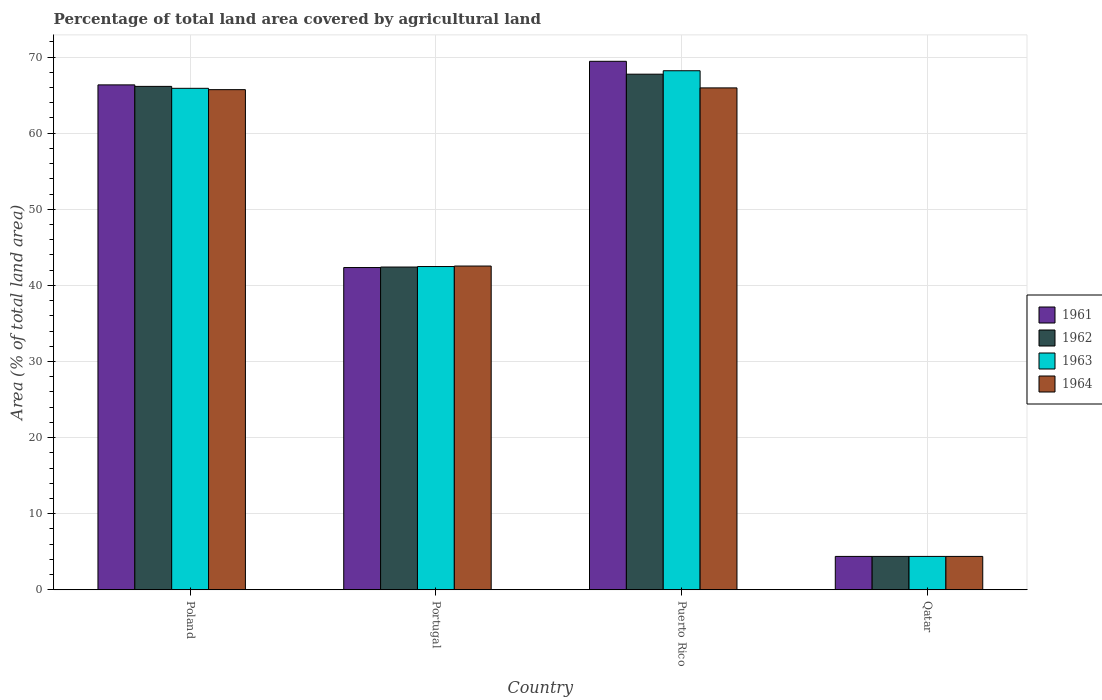How many different coloured bars are there?
Provide a short and direct response. 4. How many groups of bars are there?
Offer a terse response. 4. Are the number of bars on each tick of the X-axis equal?
Provide a succinct answer. Yes. How many bars are there on the 4th tick from the left?
Keep it short and to the point. 4. What is the label of the 3rd group of bars from the left?
Your response must be concise. Puerto Rico. What is the percentage of agricultural land in 1964 in Portugal?
Provide a short and direct response. 42.55. Across all countries, what is the maximum percentage of agricultural land in 1964?
Make the answer very short. 65.95. Across all countries, what is the minimum percentage of agricultural land in 1961?
Offer a terse response. 4.39. In which country was the percentage of agricultural land in 1964 maximum?
Offer a very short reply. Puerto Rico. In which country was the percentage of agricultural land in 1961 minimum?
Give a very brief answer. Qatar. What is the total percentage of agricultural land in 1961 in the graph?
Ensure brevity in your answer.  182.54. What is the difference between the percentage of agricultural land in 1963 in Portugal and that in Puerto Rico?
Your answer should be compact. -25.73. What is the difference between the percentage of agricultural land in 1962 in Portugal and the percentage of agricultural land in 1963 in Qatar?
Offer a terse response. 38.02. What is the average percentage of agricultural land in 1961 per country?
Your response must be concise. 45.63. What is the difference between the percentage of agricultural land of/in 1961 and percentage of agricultural land of/in 1963 in Qatar?
Provide a succinct answer. 0. In how many countries, is the percentage of agricultural land in 1963 greater than 64 %?
Your response must be concise. 2. What is the ratio of the percentage of agricultural land in 1964 in Poland to that in Portugal?
Make the answer very short. 1.54. Is the percentage of agricultural land in 1964 in Poland less than that in Puerto Rico?
Give a very brief answer. Yes. Is the difference between the percentage of agricultural land in 1961 in Poland and Qatar greater than the difference between the percentage of agricultural land in 1963 in Poland and Qatar?
Your answer should be compact. Yes. What is the difference between the highest and the second highest percentage of agricultural land in 1964?
Your response must be concise. -0.23. What is the difference between the highest and the lowest percentage of agricultural land in 1964?
Provide a short and direct response. 61.56. In how many countries, is the percentage of agricultural land in 1963 greater than the average percentage of agricultural land in 1963 taken over all countries?
Offer a very short reply. 2. Is the sum of the percentage of agricultural land in 1964 in Poland and Portugal greater than the maximum percentage of agricultural land in 1962 across all countries?
Make the answer very short. Yes. What does the 2nd bar from the right in Portugal represents?
Keep it short and to the point. 1963. Is it the case that in every country, the sum of the percentage of agricultural land in 1964 and percentage of agricultural land in 1961 is greater than the percentage of agricultural land in 1962?
Your answer should be compact. Yes. How many bars are there?
Your answer should be compact. 16. Are all the bars in the graph horizontal?
Keep it short and to the point. No. Does the graph contain grids?
Provide a succinct answer. Yes. What is the title of the graph?
Offer a very short reply. Percentage of total land area covered by agricultural land. Does "1977" appear as one of the legend labels in the graph?
Your response must be concise. No. What is the label or title of the X-axis?
Make the answer very short. Country. What is the label or title of the Y-axis?
Keep it short and to the point. Area (% of total land area). What is the Area (% of total land area) of 1961 in Poland?
Ensure brevity in your answer.  66.35. What is the Area (% of total land area) of 1962 in Poland?
Your answer should be very brief. 66.15. What is the Area (% of total land area) in 1963 in Poland?
Keep it short and to the point. 65.9. What is the Area (% of total land area) in 1964 in Poland?
Offer a terse response. 65.72. What is the Area (% of total land area) of 1961 in Portugal?
Offer a terse response. 42.35. What is the Area (% of total land area) in 1962 in Portugal?
Ensure brevity in your answer.  42.42. What is the Area (% of total land area) of 1963 in Portugal?
Make the answer very short. 42.48. What is the Area (% of total land area) in 1964 in Portugal?
Offer a terse response. 42.55. What is the Area (% of total land area) in 1961 in Puerto Rico?
Your answer should be compact. 69.45. What is the Area (% of total land area) of 1962 in Puerto Rico?
Offer a terse response. 67.76. What is the Area (% of total land area) in 1963 in Puerto Rico?
Keep it short and to the point. 68.21. What is the Area (% of total land area) in 1964 in Puerto Rico?
Provide a succinct answer. 65.95. What is the Area (% of total land area) of 1961 in Qatar?
Provide a short and direct response. 4.39. What is the Area (% of total land area) in 1962 in Qatar?
Give a very brief answer. 4.39. What is the Area (% of total land area) in 1963 in Qatar?
Ensure brevity in your answer.  4.39. What is the Area (% of total land area) of 1964 in Qatar?
Ensure brevity in your answer.  4.39. Across all countries, what is the maximum Area (% of total land area) of 1961?
Make the answer very short. 69.45. Across all countries, what is the maximum Area (% of total land area) of 1962?
Ensure brevity in your answer.  67.76. Across all countries, what is the maximum Area (% of total land area) in 1963?
Give a very brief answer. 68.21. Across all countries, what is the maximum Area (% of total land area) of 1964?
Your answer should be compact. 65.95. Across all countries, what is the minimum Area (% of total land area) of 1961?
Ensure brevity in your answer.  4.39. Across all countries, what is the minimum Area (% of total land area) of 1962?
Your answer should be compact. 4.39. Across all countries, what is the minimum Area (% of total land area) in 1963?
Ensure brevity in your answer.  4.39. Across all countries, what is the minimum Area (% of total land area) of 1964?
Provide a short and direct response. 4.39. What is the total Area (% of total land area) of 1961 in the graph?
Your response must be concise. 182.54. What is the total Area (% of total land area) of 1962 in the graph?
Provide a short and direct response. 180.72. What is the total Area (% of total land area) in 1963 in the graph?
Provide a short and direct response. 180.98. What is the total Area (% of total land area) of 1964 in the graph?
Ensure brevity in your answer.  178.61. What is the difference between the Area (% of total land area) of 1961 in Poland and that in Portugal?
Your answer should be very brief. 24. What is the difference between the Area (% of total land area) of 1962 in Poland and that in Portugal?
Keep it short and to the point. 23.74. What is the difference between the Area (% of total land area) in 1963 in Poland and that in Portugal?
Ensure brevity in your answer.  23.42. What is the difference between the Area (% of total land area) in 1964 in Poland and that in Portugal?
Offer a very short reply. 23.18. What is the difference between the Area (% of total land area) in 1961 in Poland and that in Puerto Rico?
Give a very brief answer. -3.1. What is the difference between the Area (% of total land area) in 1962 in Poland and that in Puerto Rico?
Make the answer very short. -1.6. What is the difference between the Area (% of total land area) in 1963 in Poland and that in Puerto Rico?
Your answer should be compact. -2.31. What is the difference between the Area (% of total land area) in 1964 in Poland and that in Puerto Rico?
Provide a short and direct response. -0.23. What is the difference between the Area (% of total land area) in 1961 in Poland and that in Qatar?
Your response must be concise. 61.96. What is the difference between the Area (% of total land area) of 1962 in Poland and that in Qatar?
Provide a short and direct response. 61.76. What is the difference between the Area (% of total land area) in 1963 in Poland and that in Qatar?
Make the answer very short. 61.51. What is the difference between the Area (% of total land area) of 1964 in Poland and that in Qatar?
Make the answer very short. 61.33. What is the difference between the Area (% of total land area) in 1961 in Portugal and that in Puerto Rico?
Your response must be concise. -27.1. What is the difference between the Area (% of total land area) of 1962 in Portugal and that in Puerto Rico?
Your answer should be compact. -25.34. What is the difference between the Area (% of total land area) in 1963 in Portugal and that in Puerto Rico?
Offer a terse response. -25.73. What is the difference between the Area (% of total land area) of 1964 in Portugal and that in Puerto Rico?
Provide a short and direct response. -23.41. What is the difference between the Area (% of total land area) of 1961 in Portugal and that in Qatar?
Offer a very short reply. 37.96. What is the difference between the Area (% of total land area) in 1962 in Portugal and that in Qatar?
Offer a terse response. 38.02. What is the difference between the Area (% of total land area) of 1963 in Portugal and that in Qatar?
Your answer should be compact. 38.09. What is the difference between the Area (% of total land area) of 1964 in Portugal and that in Qatar?
Provide a succinct answer. 38.15. What is the difference between the Area (% of total land area) in 1961 in Puerto Rico and that in Qatar?
Your response must be concise. 65.05. What is the difference between the Area (% of total land area) of 1962 in Puerto Rico and that in Qatar?
Your response must be concise. 63.36. What is the difference between the Area (% of total land area) of 1963 in Puerto Rico and that in Qatar?
Give a very brief answer. 63.81. What is the difference between the Area (% of total land area) in 1964 in Puerto Rico and that in Qatar?
Give a very brief answer. 61.56. What is the difference between the Area (% of total land area) of 1961 in Poland and the Area (% of total land area) of 1962 in Portugal?
Your answer should be very brief. 23.93. What is the difference between the Area (% of total land area) in 1961 in Poland and the Area (% of total land area) in 1963 in Portugal?
Ensure brevity in your answer.  23.87. What is the difference between the Area (% of total land area) in 1961 in Poland and the Area (% of total land area) in 1964 in Portugal?
Your answer should be compact. 23.8. What is the difference between the Area (% of total land area) in 1962 in Poland and the Area (% of total land area) in 1963 in Portugal?
Offer a terse response. 23.67. What is the difference between the Area (% of total land area) of 1962 in Poland and the Area (% of total land area) of 1964 in Portugal?
Make the answer very short. 23.61. What is the difference between the Area (% of total land area) of 1963 in Poland and the Area (% of total land area) of 1964 in Portugal?
Offer a very short reply. 23.35. What is the difference between the Area (% of total land area) of 1961 in Poland and the Area (% of total land area) of 1962 in Puerto Rico?
Your answer should be compact. -1.41. What is the difference between the Area (% of total land area) of 1961 in Poland and the Area (% of total land area) of 1963 in Puerto Rico?
Offer a terse response. -1.86. What is the difference between the Area (% of total land area) in 1961 in Poland and the Area (% of total land area) in 1964 in Puerto Rico?
Provide a short and direct response. 0.4. What is the difference between the Area (% of total land area) in 1962 in Poland and the Area (% of total land area) in 1963 in Puerto Rico?
Your answer should be compact. -2.05. What is the difference between the Area (% of total land area) of 1962 in Poland and the Area (% of total land area) of 1964 in Puerto Rico?
Your answer should be compact. 0.2. What is the difference between the Area (% of total land area) in 1963 in Poland and the Area (% of total land area) in 1964 in Puerto Rico?
Give a very brief answer. -0.05. What is the difference between the Area (% of total land area) of 1961 in Poland and the Area (% of total land area) of 1962 in Qatar?
Offer a very short reply. 61.96. What is the difference between the Area (% of total land area) in 1961 in Poland and the Area (% of total land area) in 1963 in Qatar?
Make the answer very short. 61.96. What is the difference between the Area (% of total land area) of 1961 in Poland and the Area (% of total land area) of 1964 in Qatar?
Your answer should be compact. 61.96. What is the difference between the Area (% of total land area) in 1962 in Poland and the Area (% of total land area) in 1963 in Qatar?
Your response must be concise. 61.76. What is the difference between the Area (% of total land area) in 1962 in Poland and the Area (% of total land area) in 1964 in Qatar?
Keep it short and to the point. 61.76. What is the difference between the Area (% of total land area) of 1963 in Poland and the Area (% of total land area) of 1964 in Qatar?
Offer a very short reply. 61.51. What is the difference between the Area (% of total land area) of 1961 in Portugal and the Area (% of total land area) of 1962 in Puerto Rico?
Make the answer very short. -25.41. What is the difference between the Area (% of total land area) in 1961 in Portugal and the Area (% of total land area) in 1963 in Puerto Rico?
Provide a short and direct response. -25.86. What is the difference between the Area (% of total land area) of 1961 in Portugal and the Area (% of total land area) of 1964 in Puerto Rico?
Keep it short and to the point. -23.6. What is the difference between the Area (% of total land area) of 1962 in Portugal and the Area (% of total land area) of 1963 in Puerto Rico?
Your answer should be compact. -25.79. What is the difference between the Area (% of total land area) in 1962 in Portugal and the Area (% of total land area) in 1964 in Puerto Rico?
Provide a succinct answer. -23.54. What is the difference between the Area (% of total land area) in 1963 in Portugal and the Area (% of total land area) in 1964 in Puerto Rico?
Give a very brief answer. -23.47. What is the difference between the Area (% of total land area) in 1961 in Portugal and the Area (% of total land area) in 1962 in Qatar?
Your answer should be very brief. 37.96. What is the difference between the Area (% of total land area) in 1961 in Portugal and the Area (% of total land area) in 1963 in Qatar?
Provide a succinct answer. 37.96. What is the difference between the Area (% of total land area) in 1961 in Portugal and the Area (% of total land area) in 1964 in Qatar?
Keep it short and to the point. 37.96. What is the difference between the Area (% of total land area) of 1962 in Portugal and the Area (% of total land area) of 1963 in Qatar?
Give a very brief answer. 38.02. What is the difference between the Area (% of total land area) of 1962 in Portugal and the Area (% of total land area) of 1964 in Qatar?
Provide a short and direct response. 38.02. What is the difference between the Area (% of total land area) of 1963 in Portugal and the Area (% of total land area) of 1964 in Qatar?
Offer a very short reply. 38.09. What is the difference between the Area (% of total land area) of 1961 in Puerto Rico and the Area (% of total land area) of 1962 in Qatar?
Your answer should be very brief. 65.05. What is the difference between the Area (% of total land area) of 1961 in Puerto Rico and the Area (% of total land area) of 1963 in Qatar?
Give a very brief answer. 65.05. What is the difference between the Area (% of total land area) in 1961 in Puerto Rico and the Area (% of total land area) in 1964 in Qatar?
Provide a succinct answer. 65.05. What is the difference between the Area (% of total land area) of 1962 in Puerto Rico and the Area (% of total land area) of 1963 in Qatar?
Offer a very short reply. 63.36. What is the difference between the Area (% of total land area) in 1962 in Puerto Rico and the Area (% of total land area) in 1964 in Qatar?
Provide a succinct answer. 63.36. What is the difference between the Area (% of total land area) of 1963 in Puerto Rico and the Area (% of total land area) of 1964 in Qatar?
Your answer should be very brief. 63.81. What is the average Area (% of total land area) in 1961 per country?
Provide a succinct answer. 45.63. What is the average Area (% of total land area) of 1962 per country?
Provide a short and direct response. 45.18. What is the average Area (% of total land area) in 1963 per country?
Your answer should be compact. 45.24. What is the average Area (% of total land area) in 1964 per country?
Your answer should be very brief. 44.65. What is the difference between the Area (% of total land area) in 1961 and Area (% of total land area) in 1962 in Poland?
Your response must be concise. 0.2. What is the difference between the Area (% of total land area) in 1961 and Area (% of total land area) in 1963 in Poland?
Make the answer very short. 0.45. What is the difference between the Area (% of total land area) in 1961 and Area (% of total land area) in 1964 in Poland?
Your response must be concise. 0.63. What is the difference between the Area (% of total land area) of 1962 and Area (% of total land area) of 1963 in Poland?
Make the answer very short. 0.25. What is the difference between the Area (% of total land area) in 1962 and Area (% of total land area) in 1964 in Poland?
Provide a short and direct response. 0.43. What is the difference between the Area (% of total land area) in 1963 and Area (% of total land area) in 1964 in Poland?
Make the answer very short. 0.18. What is the difference between the Area (% of total land area) of 1961 and Area (% of total land area) of 1962 in Portugal?
Offer a terse response. -0.07. What is the difference between the Area (% of total land area) of 1961 and Area (% of total land area) of 1963 in Portugal?
Make the answer very short. -0.13. What is the difference between the Area (% of total land area) of 1961 and Area (% of total land area) of 1964 in Portugal?
Provide a succinct answer. -0.2. What is the difference between the Area (% of total land area) in 1962 and Area (% of total land area) in 1963 in Portugal?
Offer a very short reply. -0.07. What is the difference between the Area (% of total land area) in 1962 and Area (% of total land area) in 1964 in Portugal?
Offer a very short reply. -0.13. What is the difference between the Area (% of total land area) in 1963 and Area (% of total land area) in 1964 in Portugal?
Provide a succinct answer. -0.07. What is the difference between the Area (% of total land area) of 1961 and Area (% of total land area) of 1962 in Puerto Rico?
Provide a succinct answer. 1.69. What is the difference between the Area (% of total land area) of 1961 and Area (% of total land area) of 1963 in Puerto Rico?
Provide a succinct answer. 1.24. What is the difference between the Area (% of total land area) of 1961 and Area (% of total land area) of 1964 in Puerto Rico?
Ensure brevity in your answer.  3.49. What is the difference between the Area (% of total land area) of 1962 and Area (% of total land area) of 1963 in Puerto Rico?
Offer a very short reply. -0.45. What is the difference between the Area (% of total land area) in 1962 and Area (% of total land area) in 1964 in Puerto Rico?
Offer a terse response. 1.8. What is the difference between the Area (% of total land area) in 1963 and Area (% of total land area) in 1964 in Puerto Rico?
Provide a short and direct response. 2.25. What is the difference between the Area (% of total land area) of 1961 and Area (% of total land area) of 1962 in Qatar?
Ensure brevity in your answer.  0. What is the difference between the Area (% of total land area) in 1961 and Area (% of total land area) in 1963 in Qatar?
Offer a terse response. 0. What is the difference between the Area (% of total land area) in 1962 and Area (% of total land area) in 1963 in Qatar?
Offer a very short reply. 0. What is the difference between the Area (% of total land area) in 1963 and Area (% of total land area) in 1964 in Qatar?
Keep it short and to the point. 0. What is the ratio of the Area (% of total land area) of 1961 in Poland to that in Portugal?
Keep it short and to the point. 1.57. What is the ratio of the Area (% of total land area) of 1962 in Poland to that in Portugal?
Give a very brief answer. 1.56. What is the ratio of the Area (% of total land area) in 1963 in Poland to that in Portugal?
Offer a very short reply. 1.55. What is the ratio of the Area (% of total land area) of 1964 in Poland to that in Portugal?
Make the answer very short. 1.54. What is the ratio of the Area (% of total land area) of 1961 in Poland to that in Puerto Rico?
Ensure brevity in your answer.  0.96. What is the ratio of the Area (% of total land area) in 1962 in Poland to that in Puerto Rico?
Provide a short and direct response. 0.98. What is the ratio of the Area (% of total land area) in 1963 in Poland to that in Puerto Rico?
Your response must be concise. 0.97. What is the ratio of the Area (% of total land area) of 1961 in Poland to that in Qatar?
Your answer should be very brief. 15.1. What is the ratio of the Area (% of total land area) in 1962 in Poland to that in Qatar?
Your response must be concise. 15.06. What is the ratio of the Area (% of total land area) in 1963 in Poland to that in Qatar?
Your response must be concise. 15. What is the ratio of the Area (% of total land area) in 1964 in Poland to that in Qatar?
Provide a succinct answer. 14.96. What is the ratio of the Area (% of total land area) of 1961 in Portugal to that in Puerto Rico?
Provide a succinct answer. 0.61. What is the ratio of the Area (% of total land area) of 1962 in Portugal to that in Puerto Rico?
Your answer should be compact. 0.63. What is the ratio of the Area (% of total land area) of 1963 in Portugal to that in Puerto Rico?
Offer a very short reply. 0.62. What is the ratio of the Area (% of total land area) in 1964 in Portugal to that in Puerto Rico?
Your answer should be very brief. 0.65. What is the ratio of the Area (% of total land area) of 1961 in Portugal to that in Qatar?
Provide a succinct answer. 9.64. What is the ratio of the Area (% of total land area) in 1962 in Portugal to that in Qatar?
Offer a very short reply. 9.66. What is the ratio of the Area (% of total land area) of 1963 in Portugal to that in Qatar?
Your answer should be compact. 9.67. What is the ratio of the Area (% of total land area) of 1964 in Portugal to that in Qatar?
Offer a terse response. 9.69. What is the ratio of the Area (% of total land area) in 1961 in Puerto Rico to that in Qatar?
Ensure brevity in your answer.  15.81. What is the ratio of the Area (% of total land area) in 1962 in Puerto Rico to that in Qatar?
Your answer should be very brief. 15.42. What is the ratio of the Area (% of total land area) in 1963 in Puerto Rico to that in Qatar?
Your response must be concise. 15.53. What is the ratio of the Area (% of total land area) of 1964 in Puerto Rico to that in Qatar?
Your response must be concise. 15.01. What is the difference between the highest and the second highest Area (% of total land area) in 1961?
Your answer should be very brief. 3.1. What is the difference between the highest and the second highest Area (% of total land area) of 1962?
Offer a very short reply. 1.6. What is the difference between the highest and the second highest Area (% of total land area) of 1963?
Offer a very short reply. 2.31. What is the difference between the highest and the second highest Area (% of total land area) in 1964?
Your answer should be compact. 0.23. What is the difference between the highest and the lowest Area (% of total land area) in 1961?
Offer a terse response. 65.05. What is the difference between the highest and the lowest Area (% of total land area) of 1962?
Your response must be concise. 63.36. What is the difference between the highest and the lowest Area (% of total land area) in 1963?
Offer a terse response. 63.81. What is the difference between the highest and the lowest Area (% of total land area) of 1964?
Your response must be concise. 61.56. 